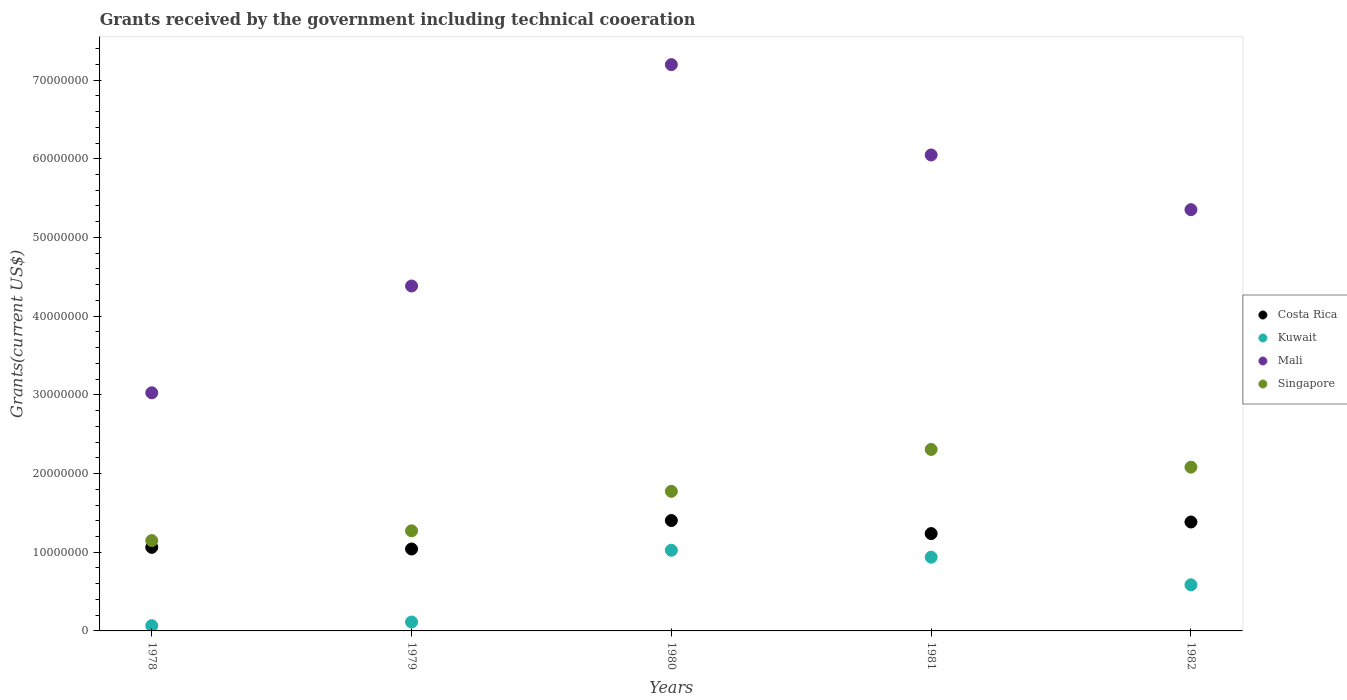How many different coloured dotlines are there?
Offer a terse response. 4. What is the total grants received by the government in Kuwait in 1981?
Offer a terse response. 9.37e+06. Across all years, what is the maximum total grants received by the government in Costa Rica?
Provide a succinct answer. 1.40e+07. Across all years, what is the minimum total grants received by the government in Kuwait?
Your answer should be compact. 6.70e+05. In which year was the total grants received by the government in Kuwait maximum?
Make the answer very short. 1980. In which year was the total grants received by the government in Kuwait minimum?
Offer a terse response. 1978. What is the total total grants received by the government in Singapore in the graph?
Ensure brevity in your answer.  8.58e+07. What is the difference between the total grants received by the government in Mali in 1978 and that in 1981?
Provide a short and direct response. -3.02e+07. What is the difference between the total grants received by the government in Mali in 1979 and the total grants received by the government in Costa Rica in 1978?
Your answer should be very brief. 3.32e+07. What is the average total grants received by the government in Kuwait per year?
Provide a succinct answer. 5.46e+06. What is the ratio of the total grants received by the government in Costa Rica in 1978 to that in 1982?
Offer a very short reply. 0.77. Is the total grants received by the government in Costa Rica in 1980 less than that in 1981?
Offer a terse response. No. Is the difference between the total grants received by the government in Costa Rica in 1979 and 1982 greater than the difference between the total grants received by the government in Kuwait in 1979 and 1982?
Your response must be concise. Yes. What is the difference between the highest and the second highest total grants received by the government in Kuwait?
Your answer should be compact. 8.80e+05. What is the difference between the highest and the lowest total grants received by the government in Mali?
Provide a succinct answer. 4.17e+07. Is it the case that in every year, the sum of the total grants received by the government in Costa Rica and total grants received by the government in Kuwait  is greater than the sum of total grants received by the government in Singapore and total grants received by the government in Mali?
Make the answer very short. Yes. Is the total grants received by the government in Mali strictly less than the total grants received by the government in Kuwait over the years?
Your answer should be compact. No. How many dotlines are there?
Keep it short and to the point. 4. How many years are there in the graph?
Give a very brief answer. 5. What is the difference between two consecutive major ticks on the Y-axis?
Offer a very short reply. 1.00e+07. Does the graph contain grids?
Keep it short and to the point. No. How many legend labels are there?
Keep it short and to the point. 4. How are the legend labels stacked?
Offer a very short reply. Vertical. What is the title of the graph?
Ensure brevity in your answer.  Grants received by the government including technical cooeration. Does "Iraq" appear as one of the legend labels in the graph?
Make the answer very short. No. What is the label or title of the Y-axis?
Your answer should be very brief. Grants(current US$). What is the Grants(current US$) in Costa Rica in 1978?
Offer a very short reply. 1.06e+07. What is the Grants(current US$) in Kuwait in 1978?
Make the answer very short. 6.70e+05. What is the Grants(current US$) in Mali in 1978?
Your answer should be very brief. 3.03e+07. What is the Grants(current US$) in Singapore in 1978?
Offer a terse response. 1.15e+07. What is the Grants(current US$) of Costa Rica in 1979?
Ensure brevity in your answer.  1.04e+07. What is the Grants(current US$) in Kuwait in 1979?
Your response must be concise. 1.13e+06. What is the Grants(current US$) of Mali in 1979?
Your response must be concise. 4.38e+07. What is the Grants(current US$) in Singapore in 1979?
Give a very brief answer. 1.27e+07. What is the Grants(current US$) of Costa Rica in 1980?
Your answer should be very brief. 1.40e+07. What is the Grants(current US$) in Kuwait in 1980?
Offer a terse response. 1.02e+07. What is the Grants(current US$) of Mali in 1980?
Provide a succinct answer. 7.20e+07. What is the Grants(current US$) of Singapore in 1980?
Ensure brevity in your answer.  1.77e+07. What is the Grants(current US$) in Costa Rica in 1981?
Your response must be concise. 1.24e+07. What is the Grants(current US$) of Kuwait in 1981?
Make the answer very short. 9.37e+06. What is the Grants(current US$) of Mali in 1981?
Your answer should be very brief. 6.05e+07. What is the Grants(current US$) in Singapore in 1981?
Keep it short and to the point. 2.31e+07. What is the Grants(current US$) in Costa Rica in 1982?
Offer a terse response. 1.38e+07. What is the Grants(current US$) in Kuwait in 1982?
Your answer should be compact. 5.86e+06. What is the Grants(current US$) of Mali in 1982?
Keep it short and to the point. 5.35e+07. What is the Grants(current US$) in Singapore in 1982?
Make the answer very short. 2.08e+07. Across all years, what is the maximum Grants(current US$) in Costa Rica?
Make the answer very short. 1.40e+07. Across all years, what is the maximum Grants(current US$) in Kuwait?
Give a very brief answer. 1.02e+07. Across all years, what is the maximum Grants(current US$) of Mali?
Your answer should be very brief. 7.20e+07. Across all years, what is the maximum Grants(current US$) in Singapore?
Keep it short and to the point. 2.31e+07. Across all years, what is the minimum Grants(current US$) in Costa Rica?
Give a very brief answer. 1.04e+07. Across all years, what is the minimum Grants(current US$) of Kuwait?
Offer a terse response. 6.70e+05. Across all years, what is the minimum Grants(current US$) in Mali?
Keep it short and to the point. 3.03e+07. Across all years, what is the minimum Grants(current US$) in Singapore?
Provide a short and direct response. 1.15e+07. What is the total Grants(current US$) of Costa Rica in the graph?
Your response must be concise. 6.13e+07. What is the total Grants(current US$) of Kuwait in the graph?
Offer a terse response. 2.73e+07. What is the total Grants(current US$) of Mali in the graph?
Offer a very short reply. 2.60e+08. What is the total Grants(current US$) in Singapore in the graph?
Your answer should be very brief. 8.58e+07. What is the difference between the Grants(current US$) of Kuwait in 1978 and that in 1979?
Your answer should be compact. -4.60e+05. What is the difference between the Grants(current US$) of Mali in 1978 and that in 1979?
Ensure brevity in your answer.  -1.36e+07. What is the difference between the Grants(current US$) in Singapore in 1978 and that in 1979?
Your answer should be very brief. -1.24e+06. What is the difference between the Grants(current US$) in Costa Rica in 1978 and that in 1980?
Your answer should be compact. -3.41e+06. What is the difference between the Grants(current US$) in Kuwait in 1978 and that in 1980?
Offer a very short reply. -9.58e+06. What is the difference between the Grants(current US$) in Mali in 1978 and that in 1980?
Provide a short and direct response. -4.17e+07. What is the difference between the Grants(current US$) in Singapore in 1978 and that in 1980?
Keep it short and to the point. -6.26e+06. What is the difference between the Grants(current US$) in Costa Rica in 1978 and that in 1981?
Provide a succinct answer. -1.75e+06. What is the difference between the Grants(current US$) of Kuwait in 1978 and that in 1981?
Ensure brevity in your answer.  -8.70e+06. What is the difference between the Grants(current US$) in Mali in 1978 and that in 1981?
Make the answer very short. -3.02e+07. What is the difference between the Grants(current US$) in Singapore in 1978 and that in 1981?
Make the answer very short. -1.16e+07. What is the difference between the Grants(current US$) of Costa Rica in 1978 and that in 1982?
Make the answer very short. -3.22e+06. What is the difference between the Grants(current US$) of Kuwait in 1978 and that in 1982?
Provide a short and direct response. -5.19e+06. What is the difference between the Grants(current US$) in Mali in 1978 and that in 1982?
Provide a succinct answer. -2.33e+07. What is the difference between the Grants(current US$) in Singapore in 1978 and that in 1982?
Make the answer very short. -9.33e+06. What is the difference between the Grants(current US$) of Costa Rica in 1979 and that in 1980?
Your answer should be compact. -3.62e+06. What is the difference between the Grants(current US$) of Kuwait in 1979 and that in 1980?
Ensure brevity in your answer.  -9.12e+06. What is the difference between the Grants(current US$) in Mali in 1979 and that in 1980?
Your answer should be very brief. -2.81e+07. What is the difference between the Grants(current US$) in Singapore in 1979 and that in 1980?
Your answer should be very brief. -5.02e+06. What is the difference between the Grants(current US$) in Costa Rica in 1979 and that in 1981?
Offer a terse response. -1.96e+06. What is the difference between the Grants(current US$) in Kuwait in 1979 and that in 1981?
Provide a short and direct response. -8.24e+06. What is the difference between the Grants(current US$) in Mali in 1979 and that in 1981?
Keep it short and to the point. -1.66e+07. What is the difference between the Grants(current US$) in Singapore in 1979 and that in 1981?
Give a very brief answer. -1.03e+07. What is the difference between the Grants(current US$) of Costa Rica in 1979 and that in 1982?
Keep it short and to the point. -3.43e+06. What is the difference between the Grants(current US$) of Kuwait in 1979 and that in 1982?
Make the answer very short. -4.73e+06. What is the difference between the Grants(current US$) in Mali in 1979 and that in 1982?
Your answer should be compact. -9.70e+06. What is the difference between the Grants(current US$) in Singapore in 1979 and that in 1982?
Keep it short and to the point. -8.09e+06. What is the difference between the Grants(current US$) of Costa Rica in 1980 and that in 1981?
Ensure brevity in your answer.  1.66e+06. What is the difference between the Grants(current US$) in Kuwait in 1980 and that in 1981?
Your answer should be compact. 8.80e+05. What is the difference between the Grants(current US$) in Mali in 1980 and that in 1981?
Offer a very short reply. 1.15e+07. What is the difference between the Grants(current US$) of Singapore in 1980 and that in 1981?
Offer a terse response. -5.32e+06. What is the difference between the Grants(current US$) of Costa Rica in 1980 and that in 1982?
Offer a terse response. 1.90e+05. What is the difference between the Grants(current US$) in Kuwait in 1980 and that in 1982?
Provide a succinct answer. 4.39e+06. What is the difference between the Grants(current US$) of Mali in 1980 and that in 1982?
Make the answer very short. 1.84e+07. What is the difference between the Grants(current US$) in Singapore in 1980 and that in 1982?
Keep it short and to the point. -3.07e+06. What is the difference between the Grants(current US$) of Costa Rica in 1981 and that in 1982?
Keep it short and to the point. -1.47e+06. What is the difference between the Grants(current US$) of Kuwait in 1981 and that in 1982?
Make the answer very short. 3.51e+06. What is the difference between the Grants(current US$) in Mali in 1981 and that in 1982?
Keep it short and to the point. 6.95e+06. What is the difference between the Grants(current US$) in Singapore in 1981 and that in 1982?
Make the answer very short. 2.25e+06. What is the difference between the Grants(current US$) of Costa Rica in 1978 and the Grants(current US$) of Kuwait in 1979?
Your response must be concise. 9.49e+06. What is the difference between the Grants(current US$) in Costa Rica in 1978 and the Grants(current US$) in Mali in 1979?
Provide a short and direct response. -3.32e+07. What is the difference between the Grants(current US$) of Costa Rica in 1978 and the Grants(current US$) of Singapore in 1979?
Keep it short and to the point. -2.10e+06. What is the difference between the Grants(current US$) of Kuwait in 1978 and the Grants(current US$) of Mali in 1979?
Your answer should be compact. -4.32e+07. What is the difference between the Grants(current US$) in Kuwait in 1978 and the Grants(current US$) in Singapore in 1979?
Your answer should be very brief. -1.20e+07. What is the difference between the Grants(current US$) of Mali in 1978 and the Grants(current US$) of Singapore in 1979?
Keep it short and to the point. 1.75e+07. What is the difference between the Grants(current US$) in Costa Rica in 1978 and the Grants(current US$) in Mali in 1980?
Your response must be concise. -6.13e+07. What is the difference between the Grants(current US$) in Costa Rica in 1978 and the Grants(current US$) in Singapore in 1980?
Ensure brevity in your answer.  -7.12e+06. What is the difference between the Grants(current US$) in Kuwait in 1978 and the Grants(current US$) in Mali in 1980?
Provide a short and direct response. -7.13e+07. What is the difference between the Grants(current US$) in Kuwait in 1978 and the Grants(current US$) in Singapore in 1980?
Your response must be concise. -1.71e+07. What is the difference between the Grants(current US$) in Mali in 1978 and the Grants(current US$) in Singapore in 1980?
Your answer should be compact. 1.25e+07. What is the difference between the Grants(current US$) in Costa Rica in 1978 and the Grants(current US$) in Kuwait in 1981?
Offer a terse response. 1.25e+06. What is the difference between the Grants(current US$) in Costa Rica in 1978 and the Grants(current US$) in Mali in 1981?
Provide a succinct answer. -4.99e+07. What is the difference between the Grants(current US$) of Costa Rica in 1978 and the Grants(current US$) of Singapore in 1981?
Ensure brevity in your answer.  -1.24e+07. What is the difference between the Grants(current US$) in Kuwait in 1978 and the Grants(current US$) in Mali in 1981?
Provide a succinct answer. -5.98e+07. What is the difference between the Grants(current US$) of Kuwait in 1978 and the Grants(current US$) of Singapore in 1981?
Provide a short and direct response. -2.24e+07. What is the difference between the Grants(current US$) in Mali in 1978 and the Grants(current US$) in Singapore in 1981?
Offer a terse response. 7.20e+06. What is the difference between the Grants(current US$) in Costa Rica in 1978 and the Grants(current US$) in Kuwait in 1982?
Your answer should be compact. 4.76e+06. What is the difference between the Grants(current US$) of Costa Rica in 1978 and the Grants(current US$) of Mali in 1982?
Provide a succinct answer. -4.29e+07. What is the difference between the Grants(current US$) in Costa Rica in 1978 and the Grants(current US$) in Singapore in 1982?
Offer a terse response. -1.02e+07. What is the difference between the Grants(current US$) in Kuwait in 1978 and the Grants(current US$) in Mali in 1982?
Provide a short and direct response. -5.29e+07. What is the difference between the Grants(current US$) of Kuwait in 1978 and the Grants(current US$) of Singapore in 1982?
Provide a succinct answer. -2.01e+07. What is the difference between the Grants(current US$) of Mali in 1978 and the Grants(current US$) of Singapore in 1982?
Offer a terse response. 9.45e+06. What is the difference between the Grants(current US$) in Costa Rica in 1979 and the Grants(current US$) in Kuwait in 1980?
Make the answer very short. 1.60e+05. What is the difference between the Grants(current US$) in Costa Rica in 1979 and the Grants(current US$) in Mali in 1980?
Ensure brevity in your answer.  -6.16e+07. What is the difference between the Grants(current US$) of Costa Rica in 1979 and the Grants(current US$) of Singapore in 1980?
Provide a succinct answer. -7.33e+06. What is the difference between the Grants(current US$) of Kuwait in 1979 and the Grants(current US$) of Mali in 1980?
Ensure brevity in your answer.  -7.08e+07. What is the difference between the Grants(current US$) of Kuwait in 1979 and the Grants(current US$) of Singapore in 1980?
Your answer should be very brief. -1.66e+07. What is the difference between the Grants(current US$) in Mali in 1979 and the Grants(current US$) in Singapore in 1980?
Provide a short and direct response. 2.61e+07. What is the difference between the Grants(current US$) in Costa Rica in 1979 and the Grants(current US$) in Kuwait in 1981?
Keep it short and to the point. 1.04e+06. What is the difference between the Grants(current US$) in Costa Rica in 1979 and the Grants(current US$) in Mali in 1981?
Your response must be concise. -5.01e+07. What is the difference between the Grants(current US$) of Costa Rica in 1979 and the Grants(current US$) of Singapore in 1981?
Make the answer very short. -1.26e+07. What is the difference between the Grants(current US$) of Kuwait in 1979 and the Grants(current US$) of Mali in 1981?
Your answer should be very brief. -5.94e+07. What is the difference between the Grants(current US$) in Kuwait in 1979 and the Grants(current US$) in Singapore in 1981?
Ensure brevity in your answer.  -2.19e+07. What is the difference between the Grants(current US$) in Mali in 1979 and the Grants(current US$) in Singapore in 1981?
Provide a short and direct response. 2.08e+07. What is the difference between the Grants(current US$) in Costa Rica in 1979 and the Grants(current US$) in Kuwait in 1982?
Ensure brevity in your answer.  4.55e+06. What is the difference between the Grants(current US$) in Costa Rica in 1979 and the Grants(current US$) in Mali in 1982?
Provide a short and direct response. -4.31e+07. What is the difference between the Grants(current US$) in Costa Rica in 1979 and the Grants(current US$) in Singapore in 1982?
Keep it short and to the point. -1.04e+07. What is the difference between the Grants(current US$) in Kuwait in 1979 and the Grants(current US$) in Mali in 1982?
Provide a succinct answer. -5.24e+07. What is the difference between the Grants(current US$) in Kuwait in 1979 and the Grants(current US$) in Singapore in 1982?
Provide a short and direct response. -1.97e+07. What is the difference between the Grants(current US$) in Mali in 1979 and the Grants(current US$) in Singapore in 1982?
Provide a short and direct response. 2.30e+07. What is the difference between the Grants(current US$) of Costa Rica in 1980 and the Grants(current US$) of Kuwait in 1981?
Provide a succinct answer. 4.66e+06. What is the difference between the Grants(current US$) of Costa Rica in 1980 and the Grants(current US$) of Mali in 1981?
Offer a very short reply. -4.64e+07. What is the difference between the Grants(current US$) in Costa Rica in 1980 and the Grants(current US$) in Singapore in 1981?
Ensure brevity in your answer.  -9.03e+06. What is the difference between the Grants(current US$) of Kuwait in 1980 and the Grants(current US$) of Mali in 1981?
Give a very brief answer. -5.02e+07. What is the difference between the Grants(current US$) in Kuwait in 1980 and the Grants(current US$) in Singapore in 1981?
Offer a terse response. -1.28e+07. What is the difference between the Grants(current US$) of Mali in 1980 and the Grants(current US$) of Singapore in 1981?
Your answer should be very brief. 4.89e+07. What is the difference between the Grants(current US$) in Costa Rica in 1980 and the Grants(current US$) in Kuwait in 1982?
Provide a short and direct response. 8.17e+06. What is the difference between the Grants(current US$) in Costa Rica in 1980 and the Grants(current US$) in Mali in 1982?
Your answer should be compact. -3.95e+07. What is the difference between the Grants(current US$) in Costa Rica in 1980 and the Grants(current US$) in Singapore in 1982?
Your response must be concise. -6.78e+06. What is the difference between the Grants(current US$) of Kuwait in 1980 and the Grants(current US$) of Mali in 1982?
Offer a very short reply. -4.33e+07. What is the difference between the Grants(current US$) of Kuwait in 1980 and the Grants(current US$) of Singapore in 1982?
Make the answer very short. -1.06e+07. What is the difference between the Grants(current US$) of Mali in 1980 and the Grants(current US$) of Singapore in 1982?
Give a very brief answer. 5.12e+07. What is the difference between the Grants(current US$) of Costa Rica in 1981 and the Grants(current US$) of Kuwait in 1982?
Make the answer very short. 6.51e+06. What is the difference between the Grants(current US$) of Costa Rica in 1981 and the Grants(current US$) of Mali in 1982?
Your response must be concise. -4.12e+07. What is the difference between the Grants(current US$) of Costa Rica in 1981 and the Grants(current US$) of Singapore in 1982?
Provide a short and direct response. -8.44e+06. What is the difference between the Grants(current US$) of Kuwait in 1981 and the Grants(current US$) of Mali in 1982?
Provide a short and direct response. -4.42e+07. What is the difference between the Grants(current US$) in Kuwait in 1981 and the Grants(current US$) in Singapore in 1982?
Provide a short and direct response. -1.14e+07. What is the difference between the Grants(current US$) in Mali in 1981 and the Grants(current US$) in Singapore in 1982?
Keep it short and to the point. 3.97e+07. What is the average Grants(current US$) in Costa Rica per year?
Your answer should be compact. 1.23e+07. What is the average Grants(current US$) in Kuwait per year?
Give a very brief answer. 5.46e+06. What is the average Grants(current US$) of Mali per year?
Provide a short and direct response. 5.20e+07. What is the average Grants(current US$) in Singapore per year?
Offer a terse response. 1.72e+07. In the year 1978, what is the difference between the Grants(current US$) in Costa Rica and Grants(current US$) in Kuwait?
Give a very brief answer. 9.95e+06. In the year 1978, what is the difference between the Grants(current US$) of Costa Rica and Grants(current US$) of Mali?
Your answer should be very brief. -1.96e+07. In the year 1978, what is the difference between the Grants(current US$) in Costa Rica and Grants(current US$) in Singapore?
Ensure brevity in your answer.  -8.60e+05. In the year 1978, what is the difference between the Grants(current US$) in Kuwait and Grants(current US$) in Mali?
Your answer should be very brief. -2.96e+07. In the year 1978, what is the difference between the Grants(current US$) of Kuwait and Grants(current US$) of Singapore?
Your answer should be very brief. -1.08e+07. In the year 1978, what is the difference between the Grants(current US$) of Mali and Grants(current US$) of Singapore?
Provide a succinct answer. 1.88e+07. In the year 1979, what is the difference between the Grants(current US$) in Costa Rica and Grants(current US$) in Kuwait?
Your response must be concise. 9.28e+06. In the year 1979, what is the difference between the Grants(current US$) of Costa Rica and Grants(current US$) of Mali?
Keep it short and to the point. -3.34e+07. In the year 1979, what is the difference between the Grants(current US$) in Costa Rica and Grants(current US$) in Singapore?
Your answer should be very brief. -2.31e+06. In the year 1979, what is the difference between the Grants(current US$) of Kuwait and Grants(current US$) of Mali?
Your answer should be compact. -4.27e+07. In the year 1979, what is the difference between the Grants(current US$) of Kuwait and Grants(current US$) of Singapore?
Make the answer very short. -1.16e+07. In the year 1979, what is the difference between the Grants(current US$) of Mali and Grants(current US$) of Singapore?
Provide a short and direct response. 3.11e+07. In the year 1980, what is the difference between the Grants(current US$) in Costa Rica and Grants(current US$) in Kuwait?
Provide a succinct answer. 3.78e+06. In the year 1980, what is the difference between the Grants(current US$) of Costa Rica and Grants(current US$) of Mali?
Provide a short and direct response. -5.79e+07. In the year 1980, what is the difference between the Grants(current US$) in Costa Rica and Grants(current US$) in Singapore?
Make the answer very short. -3.71e+06. In the year 1980, what is the difference between the Grants(current US$) in Kuwait and Grants(current US$) in Mali?
Offer a very short reply. -6.17e+07. In the year 1980, what is the difference between the Grants(current US$) in Kuwait and Grants(current US$) in Singapore?
Provide a short and direct response. -7.49e+06. In the year 1980, what is the difference between the Grants(current US$) in Mali and Grants(current US$) in Singapore?
Provide a short and direct response. 5.42e+07. In the year 1981, what is the difference between the Grants(current US$) of Costa Rica and Grants(current US$) of Mali?
Your response must be concise. -4.81e+07. In the year 1981, what is the difference between the Grants(current US$) in Costa Rica and Grants(current US$) in Singapore?
Offer a terse response. -1.07e+07. In the year 1981, what is the difference between the Grants(current US$) in Kuwait and Grants(current US$) in Mali?
Your response must be concise. -5.11e+07. In the year 1981, what is the difference between the Grants(current US$) of Kuwait and Grants(current US$) of Singapore?
Make the answer very short. -1.37e+07. In the year 1981, what is the difference between the Grants(current US$) of Mali and Grants(current US$) of Singapore?
Provide a short and direct response. 3.74e+07. In the year 1982, what is the difference between the Grants(current US$) in Costa Rica and Grants(current US$) in Kuwait?
Your response must be concise. 7.98e+06. In the year 1982, what is the difference between the Grants(current US$) in Costa Rica and Grants(current US$) in Mali?
Your answer should be compact. -3.97e+07. In the year 1982, what is the difference between the Grants(current US$) in Costa Rica and Grants(current US$) in Singapore?
Make the answer very short. -6.97e+06. In the year 1982, what is the difference between the Grants(current US$) in Kuwait and Grants(current US$) in Mali?
Offer a very short reply. -4.77e+07. In the year 1982, what is the difference between the Grants(current US$) of Kuwait and Grants(current US$) of Singapore?
Give a very brief answer. -1.50e+07. In the year 1982, what is the difference between the Grants(current US$) of Mali and Grants(current US$) of Singapore?
Provide a succinct answer. 3.27e+07. What is the ratio of the Grants(current US$) of Costa Rica in 1978 to that in 1979?
Your answer should be compact. 1.02. What is the ratio of the Grants(current US$) of Kuwait in 1978 to that in 1979?
Provide a succinct answer. 0.59. What is the ratio of the Grants(current US$) of Mali in 1978 to that in 1979?
Keep it short and to the point. 0.69. What is the ratio of the Grants(current US$) of Singapore in 1978 to that in 1979?
Make the answer very short. 0.9. What is the ratio of the Grants(current US$) of Costa Rica in 1978 to that in 1980?
Ensure brevity in your answer.  0.76. What is the ratio of the Grants(current US$) in Kuwait in 1978 to that in 1980?
Your answer should be compact. 0.07. What is the ratio of the Grants(current US$) in Mali in 1978 to that in 1980?
Your response must be concise. 0.42. What is the ratio of the Grants(current US$) in Singapore in 1978 to that in 1980?
Make the answer very short. 0.65. What is the ratio of the Grants(current US$) of Costa Rica in 1978 to that in 1981?
Provide a short and direct response. 0.86. What is the ratio of the Grants(current US$) of Kuwait in 1978 to that in 1981?
Your response must be concise. 0.07. What is the ratio of the Grants(current US$) of Mali in 1978 to that in 1981?
Provide a succinct answer. 0.5. What is the ratio of the Grants(current US$) of Singapore in 1978 to that in 1981?
Your answer should be very brief. 0.5. What is the ratio of the Grants(current US$) in Costa Rica in 1978 to that in 1982?
Your response must be concise. 0.77. What is the ratio of the Grants(current US$) of Kuwait in 1978 to that in 1982?
Provide a succinct answer. 0.11. What is the ratio of the Grants(current US$) in Mali in 1978 to that in 1982?
Provide a succinct answer. 0.57. What is the ratio of the Grants(current US$) of Singapore in 1978 to that in 1982?
Offer a terse response. 0.55. What is the ratio of the Grants(current US$) in Costa Rica in 1979 to that in 1980?
Your response must be concise. 0.74. What is the ratio of the Grants(current US$) in Kuwait in 1979 to that in 1980?
Offer a terse response. 0.11. What is the ratio of the Grants(current US$) of Mali in 1979 to that in 1980?
Your answer should be compact. 0.61. What is the ratio of the Grants(current US$) in Singapore in 1979 to that in 1980?
Offer a very short reply. 0.72. What is the ratio of the Grants(current US$) of Costa Rica in 1979 to that in 1981?
Your response must be concise. 0.84. What is the ratio of the Grants(current US$) of Kuwait in 1979 to that in 1981?
Your answer should be very brief. 0.12. What is the ratio of the Grants(current US$) in Mali in 1979 to that in 1981?
Ensure brevity in your answer.  0.72. What is the ratio of the Grants(current US$) of Singapore in 1979 to that in 1981?
Your answer should be very brief. 0.55. What is the ratio of the Grants(current US$) of Costa Rica in 1979 to that in 1982?
Provide a short and direct response. 0.75. What is the ratio of the Grants(current US$) of Kuwait in 1979 to that in 1982?
Give a very brief answer. 0.19. What is the ratio of the Grants(current US$) in Mali in 1979 to that in 1982?
Ensure brevity in your answer.  0.82. What is the ratio of the Grants(current US$) of Singapore in 1979 to that in 1982?
Your answer should be compact. 0.61. What is the ratio of the Grants(current US$) of Costa Rica in 1980 to that in 1981?
Provide a short and direct response. 1.13. What is the ratio of the Grants(current US$) of Kuwait in 1980 to that in 1981?
Your answer should be very brief. 1.09. What is the ratio of the Grants(current US$) in Mali in 1980 to that in 1981?
Make the answer very short. 1.19. What is the ratio of the Grants(current US$) in Singapore in 1980 to that in 1981?
Offer a very short reply. 0.77. What is the ratio of the Grants(current US$) of Costa Rica in 1980 to that in 1982?
Make the answer very short. 1.01. What is the ratio of the Grants(current US$) of Kuwait in 1980 to that in 1982?
Provide a succinct answer. 1.75. What is the ratio of the Grants(current US$) in Mali in 1980 to that in 1982?
Offer a very short reply. 1.34. What is the ratio of the Grants(current US$) in Singapore in 1980 to that in 1982?
Give a very brief answer. 0.85. What is the ratio of the Grants(current US$) in Costa Rica in 1981 to that in 1982?
Make the answer very short. 0.89. What is the ratio of the Grants(current US$) of Kuwait in 1981 to that in 1982?
Give a very brief answer. 1.6. What is the ratio of the Grants(current US$) in Mali in 1981 to that in 1982?
Your answer should be very brief. 1.13. What is the ratio of the Grants(current US$) in Singapore in 1981 to that in 1982?
Your response must be concise. 1.11. What is the difference between the highest and the second highest Grants(current US$) in Costa Rica?
Make the answer very short. 1.90e+05. What is the difference between the highest and the second highest Grants(current US$) of Kuwait?
Keep it short and to the point. 8.80e+05. What is the difference between the highest and the second highest Grants(current US$) of Mali?
Your response must be concise. 1.15e+07. What is the difference between the highest and the second highest Grants(current US$) in Singapore?
Offer a very short reply. 2.25e+06. What is the difference between the highest and the lowest Grants(current US$) of Costa Rica?
Your answer should be compact. 3.62e+06. What is the difference between the highest and the lowest Grants(current US$) of Kuwait?
Ensure brevity in your answer.  9.58e+06. What is the difference between the highest and the lowest Grants(current US$) in Mali?
Keep it short and to the point. 4.17e+07. What is the difference between the highest and the lowest Grants(current US$) in Singapore?
Your answer should be compact. 1.16e+07. 